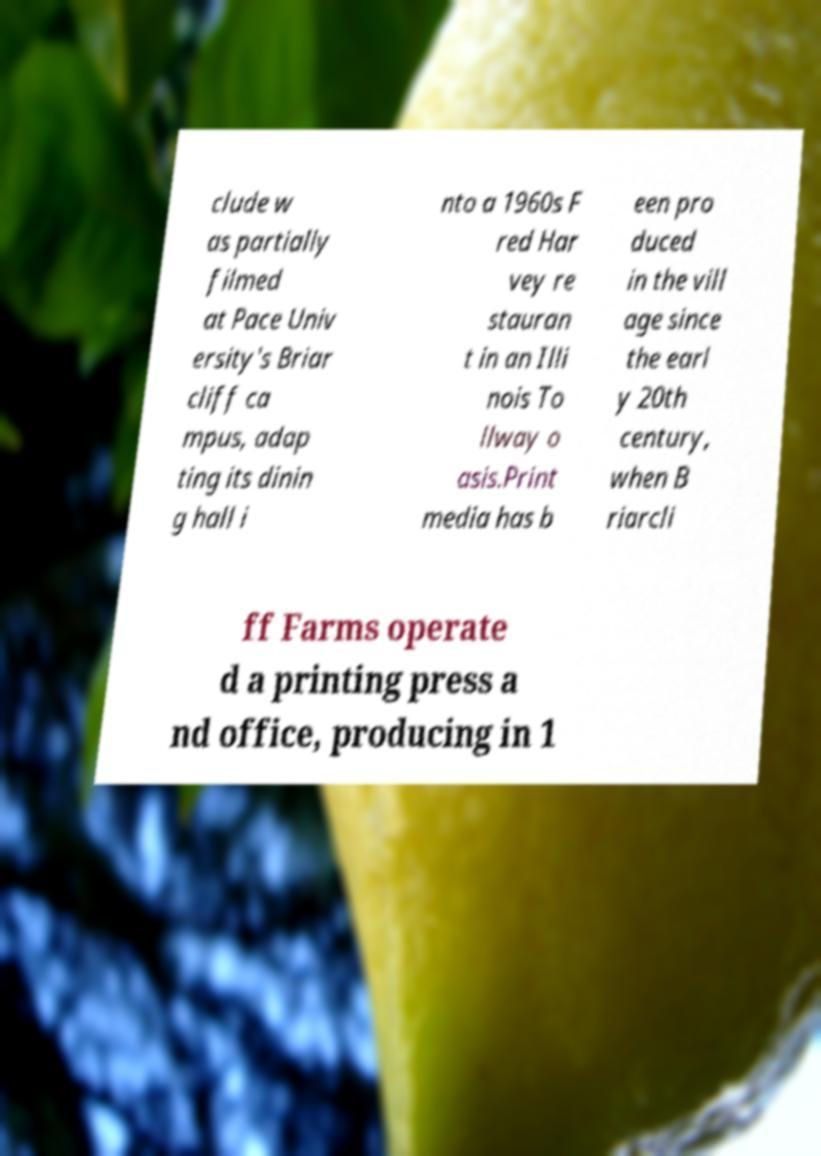Can you read and provide the text displayed in the image?This photo seems to have some interesting text. Can you extract and type it out for me? clude w as partially filmed at Pace Univ ersity's Briar cliff ca mpus, adap ting its dinin g hall i nto a 1960s F red Har vey re stauran t in an Illi nois To llway o asis.Print media has b een pro duced in the vill age since the earl y 20th century, when B riarcli ff Farms operate d a printing press a nd office, producing in 1 